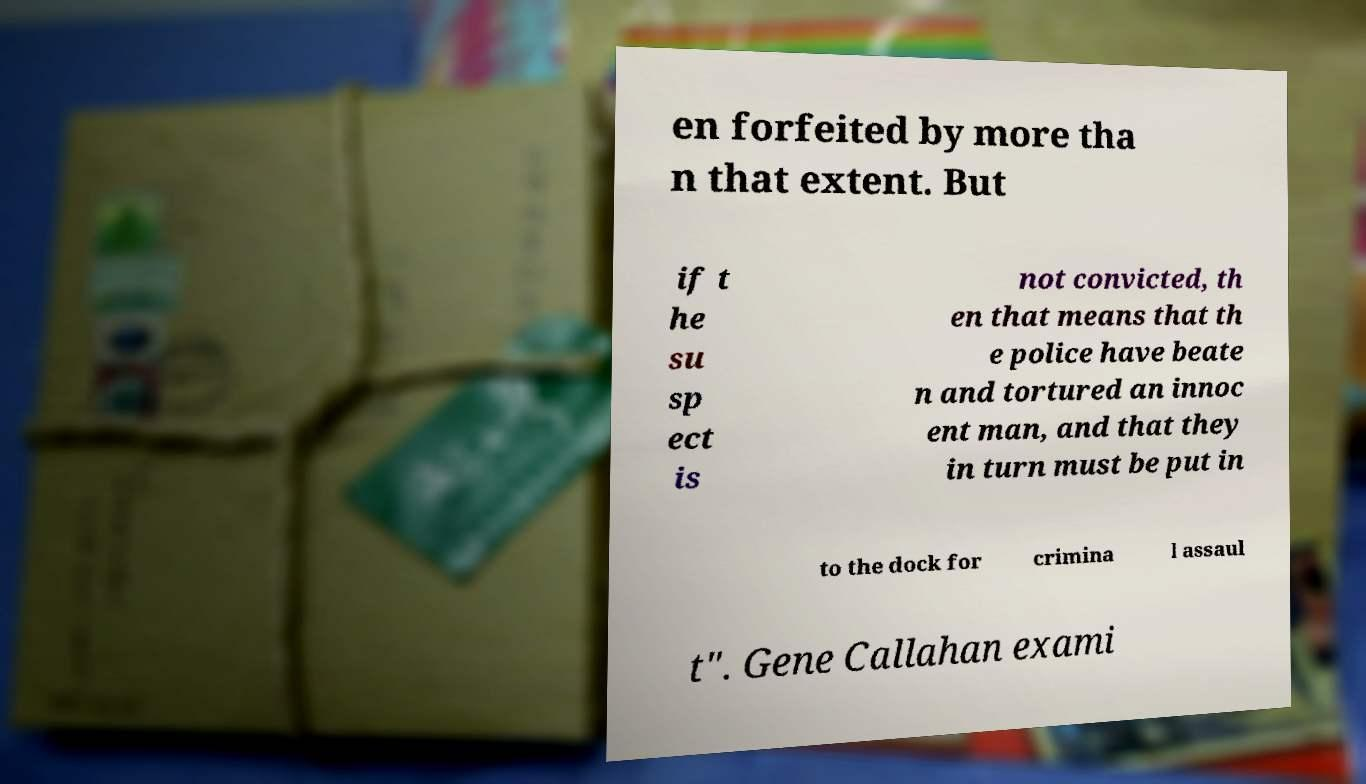There's text embedded in this image that I need extracted. Can you transcribe it verbatim? en forfeited by more tha n that extent. But if t he su sp ect is not convicted, th en that means that th e police have beate n and tortured an innoc ent man, and that they in turn must be put in to the dock for crimina l assaul t". Gene Callahan exami 